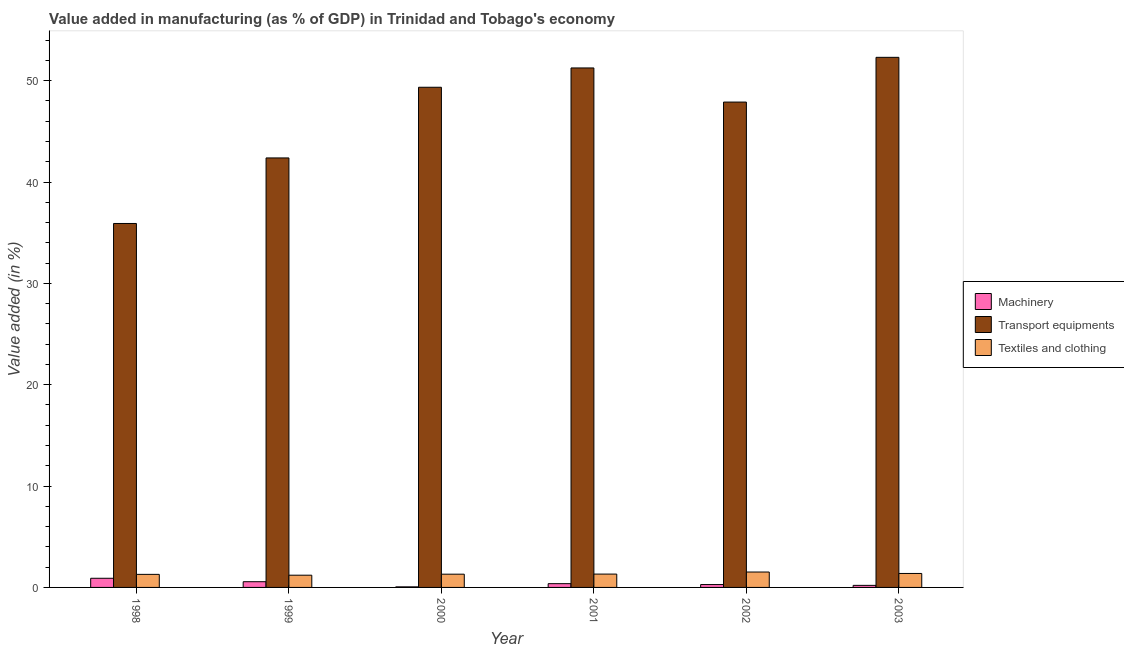How many different coloured bars are there?
Give a very brief answer. 3. How many groups of bars are there?
Make the answer very short. 6. Are the number of bars per tick equal to the number of legend labels?
Your answer should be very brief. Yes. Are the number of bars on each tick of the X-axis equal?
Your answer should be compact. Yes. How many bars are there on the 5th tick from the left?
Give a very brief answer. 3. In how many cases, is the number of bars for a given year not equal to the number of legend labels?
Provide a succinct answer. 0. What is the value added in manufacturing machinery in 2002?
Provide a succinct answer. 0.28. Across all years, what is the maximum value added in manufacturing machinery?
Give a very brief answer. 0.9. Across all years, what is the minimum value added in manufacturing transport equipments?
Ensure brevity in your answer.  35.91. In which year was the value added in manufacturing machinery minimum?
Your response must be concise. 2000. What is the total value added in manufacturing machinery in the graph?
Offer a very short reply. 2.38. What is the difference between the value added in manufacturing textile and clothing in 2000 and that in 2003?
Your answer should be compact. -0.07. What is the difference between the value added in manufacturing machinery in 2003 and the value added in manufacturing transport equipments in 2002?
Make the answer very short. -0.08. What is the average value added in manufacturing machinery per year?
Offer a terse response. 0.4. In the year 2003, what is the difference between the value added in manufacturing transport equipments and value added in manufacturing machinery?
Your answer should be very brief. 0. In how many years, is the value added in manufacturing transport equipments greater than 22 %?
Offer a very short reply. 6. What is the ratio of the value added in manufacturing machinery in 2002 to that in 2003?
Your answer should be compact. 1.39. What is the difference between the highest and the second highest value added in manufacturing transport equipments?
Keep it short and to the point. 1.05. What is the difference between the highest and the lowest value added in manufacturing machinery?
Ensure brevity in your answer.  0.85. In how many years, is the value added in manufacturing machinery greater than the average value added in manufacturing machinery taken over all years?
Provide a short and direct response. 2. What does the 3rd bar from the left in 2001 represents?
Provide a short and direct response. Textiles and clothing. What does the 2nd bar from the right in 2001 represents?
Offer a very short reply. Transport equipments. How many bars are there?
Your response must be concise. 18. Are all the bars in the graph horizontal?
Provide a short and direct response. No. How many years are there in the graph?
Your response must be concise. 6. Are the values on the major ticks of Y-axis written in scientific E-notation?
Your response must be concise. No. Does the graph contain grids?
Your answer should be very brief. No. How many legend labels are there?
Your answer should be compact. 3. How are the legend labels stacked?
Provide a succinct answer. Vertical. What is the title of the graph?
Ensure brevity in your answer.  Value added in manufacturing (as % of GDP) in Trinidad and Tobago's economy. What is the label or title of the X-axis?
Offer a terse response. Year. What is the label or title of the Y-axis?
Make the answer very short. Value added (in %). What is the Value added (in %) in Machinery in 1998?
Your answer should be very brief. 0.9. What is the Value added (in %) of Transport equipments in 1998?
Your response must be concise. 35.91. What is the Value added (in %) in Textiles and clothing in 1998?
Offer a terse response. 1.29. What is the Value added (in %) of Machinery in 1999?
Make the answer very short. 0.56. What is the Value added (in %) of Transport equipments in 1999?
Your response must be concise. 42.38. What is the Value added (in %) in Textiles and clothing in 1999?
Give a very brief answer. 1.21. What is the Value added (in %) in Machinery in 2000?
Offer a very short reply. 0.06. What is the Value added (in %) in Transport equipments in 2000?
Make the answer very short. 49.35. What is the Value added (in %) in Textiles and clothing in 2000?
Give a very brief answer. 1.31. What is the Value added (in %) in Machinery in 2001?
Provide a short and direct response. 0.37. What is the Value added (in %) in Transport equipments in 2001?
Give a very brief answer. 51.26. What is the Value added (in %) of Textiles and clothing in 2001?
Keep it short and to the point. 1.32. What is the Value added (in %) of Machinery in 2002?
Your answer should be compact. 0.28. What is the Value added (in %) of Transport equipments in 2002?
Your answer should be compact. 47.89. What is the Value added (in %) of Textiles and clothing in 2002?
Keep it short and to the point. 1.52. What is the Value added (in %) of Machinery in 2003?
Offer a terse response. 0.2. What is the Value added (in %) of Transport equipments in 2003?
Offer a very short reply. 52.3. What is the Value added (in %) of Textiles and clothing in 2003?
Offer a terse response. 1.38. Across all years, what is the maximum Value added (in %) in Machinery?
Offer a terse response. 0.9. Across all years, what is the maximum Value added (in %) of Transport equipments?
Your answer should be very brief. 52.3. Across all years, what is the maximum Value added (in %) in Textiles and clothing?
Make the answer very short. 1.52. Across all years, what is the minimum Value added (in %) of Machinery?
Give a very brief answer. 0.06. Across all years, what is the minimum Value added (in %) in Transport equipments?
Provide a short and direct response. 35.91. Across all years, what is the minimum Value added (in %) of Textiles and clothing?
Make the answer very short. 1.21. What is the total Value added (in %) of Machinery in the graph?
Make the answer very short. 2.38. What is the total Value added (in %) in Transport equipments in the graph?
Your response must be concise. 279.08. What is the total Value added (in %) of Textiles and clothing in the graph?
Provide a succinct answer. 8.02. What is the difference between the Value added (in %) in Machinery in 1998 and that in 1999?
Provide a succinct answer. 0.34. What is the difference between the Value added (in %) in Transport equipments in 1998 and that in 1999?
Your answer should be very brief. -6.47. What is the difference between the Value added (in %) of Textiles and clothing in 1998 and that in 1999?
Give a very brief answer. 0.08. What is the difference between the Value added (in %) of Machinery in 1998 and that in 2000?
Offer a terse response. 0.85. What is the difference between the Value added (in %) in Transport equipments in 1998 and that in 2000?
Keep it short and to the point. -13.44. What is the difference between the Value added (in %) in Textiles and clothing in 1998 and that in 2000?
Offer a very short reply. -0.02. What is the difference between the Value added (in %) in Machinery in 1998 and that in 2001?
Your response must be concise. 0.53. What is the difference between the Value added (in %) in Transport equipments in 1998 and that in 2001?
Give a very brief answer. -15.35. What is the difference between the Value added (in %) of Textiles and clothing in 1998 and that in 2001?
Offer a terse response. -0.03. What is the difference between the Value added (in %) of Machinery in 1998 and that in 2002?
Keep it short and to the point. 0.62. What is the difference between the Value added (in %) in Transport equipments in 1998 and that in 2002?
Your response must be concise. -11.98. What is the difference between the Value added (in %) in Textiles and clothing in 1998 and that in 2002?
Provide a succinct answer. -0.23. What is the difference between the Value added (in %) of Machinery in 1998 and that in 2003?
Give a very brief answer. 0.7. What is the difference between the Value added (in %) of Transport equipments in 1998 and that in 2003?
Make the answer very short. -16.39. What is the difference between the Value added (in %) in Textiles and clothing in 1998 and that in 2003?
Make the answer very short. -0.09. What is the difference between the Value added (in %) of Machinery in 1999 and that in 2000?
Provide a succinct answer. 0.51. What is the difference between the Value added (in %) in Transport equipments in 1999 and that in 2000?
Provide a succinct answer. -6.97. What is the difference between the Value added (in %) in Textiles and clothing in 1999 and that in 2000?
Provide a short and direct response. -0.1. What is the difference between the Value added (in %) in Machinery in 1999 and that in 2001?
Offer a terse response. 0.19. What is the difference between the Value added (in %) of Transport equipments in 1999 and that in 2001?
Make the answer very short. -8.88. What is the difference between the Value added (in %) in Textiles and clothing in 1999 and that in 2001?
Your response must be concise. -0.11. What is the difference between the Value added (in %) in Machinery in 1999 and that in 2002?
Provide a short and direct response. 0.28. What is the difference between the Value added (in %) of Transport equipments in 1999 and that in 2002?
Provide a short and direct response. -5.51. What is the difference between the Value added (in %) of Textiles and clothing in 1999 and that in 2002?
Make the answer very short. -0.31. What is the difference between the Value added (in %) in Machinery in 1999 and that in 2003?
Provide a short and direct response. 0.36. What is the difference between the Value added (in %) in Transport equipments in 1999 and that in 2003?
Provide a succinct answer. -9.93. What is the difference between the Value added (in %) of Textiles and clothing in 1999 and that in 2003?
Offer a terse response. -0.17. What is the difference between the Value added (in %) in Machinery in 2000 and that in 2001?
Make the answer very short. -0.31. What is the difference between the Value added (in %) in Transport equipments in 2000 and that in 2001?
Give a very brief answer. -1.91. What is the difference between the Value added (in %) of Textiles and clothing in 2000 and that in 2001?
Give a very brief answer. -0.01. What is the difference between the Value added (in %) of Machinery in 2000 and that in 2002?
Your answer should be compact. -0.23. What is the difference between the Value added (in %) in Transport equipments in 2000 and that in 2002?
Ensure brevity in your answer.  1.46. What is the difference between the Value added (in %) of Textiles and clothing in 2000 and that in 2002?
Make the answer very short. -0.21. What is the difference between the Value added (in %) in Machinery in 2000 and that in 2003?
Your answer should be compact. -0.15. What is the difference between the Value added (in %) of Transport equipments in 2000 and that in 2003?
Give a very brief answer. -2.95. What is the difference between the Value added (in %) of Textiles and clothing in 2000 and that in 2003?
Make the answer very short. -0.07. What is the difference between the Value added (in %) in Machinery in 2001 and that in 2002?
Make the answer very short. 0.09. What is the difference between the Value added (in %) of Transport equipments in 2001 and that in 2002?
Keep it short and to the point. 3.37. What is the difference between the Value added (in %) in Textiles and clothing in 2001 and that in 2002?
Keep it short and to the point. -0.2. What is the difference between the Value added (in %) in Machinery in 2001 and that in 2003?
Your answer should be very brief. 0.17. What is the difference between the Value added (in %) in Transport equipments in 2001 and that in 2003?
Make the answer very short. -1.05. What is the difference between the Value added (in %) of Textiles and clothing in 2001 and that in 2003?
Keep it short and to the point. -0.06. What is the difference between the Value added (in %) in Machinery in 2002 and that in 2003?
Your answer should be compact. 0.08. What is the difference between the Value added (in %) of Transport equipments in 2002 and that in 2003?
Offer a very short reply. -4.41. What is the difference between the Value added (in %) in Textiles and clothing in 2002 and that in 2003?
Offer a terse response. 0.14. What is the difference between the Value added (in %) in Machinery in 1998 and the Value added (in %) in Transport equipments in 1999?
Your response must be concise. -41.47. What is the difference between the Value added (in %) in Machinery in 1998 and the Value added (in %) in Textiles and clothing in 1999?
Provide a succinct answer. -0.3. What is the difference between the Value added (in %) of Transport equipments in 1998 and the Value added (in %) of Textiles and clothing in 1999?
Your answer should be very brief. 34.7. What is the difference between the Value added (in %) in Machinery in 1998 and the Value added (in %) in Transport equipments in 2000?
Make the answer very short. -48.45. What is the difference between the Value added (in %) of Machinery in 1998 and the Value added (in %) of Textiles and clothing in 2000?
Provide a short and direct response. -0.4. What is the difference between the Value added (in %) of Transport equipments in 1998 and the Value added (in %) of Textiles and clothing in 2000?
Provide a short and direct response. 34.6. What is the difference between the Value added (in %) of Machinery in 1998 and the Value added (in %) of Transport equipments in 2001?
Provide a succinct answer. -50.35. What is the difference between the Value added (in %) in Machinery in 1998 and the Value added (in %) in Textiles and clothing in 2001?
Keep it short and to the point. -0.41. What is the difference between the Value added (in %) in Transport equipments in 1998 and the Value added (in %) in Textiles and clothing in 2001?
Provide a succinct answer. 34.59. What is the difference between the Value added (in %) in Machinery in 1998 and the Value added (in %) in Transport equipments in 2002?
Your response must be concise. -46.99. What is the difference between the Value added (in %) of Machinery in 1998 and the Value added (in %) of Textiles and clothing in 2002?
Provide a short and direct response. -0.62. What is the difference between the Value added (in %) in Transport equipments in 1998 and the Value added (in %) in Textiles and clothing in 2002?
Provide a succinct answer. 34.39. What is the difference between the Value added (in %) in Machinery in 1998 and the Value added (in %) in Transport equipments in 2003?
Offer a very short reply. -51.4. What is the difference between the Value added (in %) of Machinery in 1998 and the Value added (in %) of Textiles and clothing in 2003?
Your answer should be compact. -0.48. What is the difference between the Value added (in %) in Transport equipments in 1998 and the Value added (in %) in Textiles and clothing in 2003?
Your answer should be compact. 34.53. What is the difference between the Value added (in %) of Machinery in 1999 and the Value added (in %) of Transport equipments in 2000?
Your response must be concise. -48.79. What is the difference between the Value added (in %) in Machinery in 1999 and the Value added (in %) in Textiles and clothing in 2000?
Your answer should be very brief. -0.74. What is the difference between the Value added (in %) of Transport equipments in 1999 and the Value added (in %) of Textiles and clothing in 2000?
Provide a short and direct response. 41.07. What is the difference between the Value added (in %) in Machinery in 1999 and the Value added (in %) in Transport equipments in 2001?
Offer a very short reply. -50.69. What is the difference between the Value added (in %) of Machinery in 1999 and the Value added (in %) of Textiles and clothing in 2001?
Keep it short and to the point. -0.75. What is the difference between the Value added (in %) in Transport equipments in 1999 and the Value added (in %) in Textiles and clothing in 2001?
Keep it short and to the point. 41.06. What is the difference between the Value added (in %) in Machinery in 1999 and the Value added (in %) in Transport equipments in 2002?
Your response must be concise. -47.32. What is the difference between the Value added (in %) of Machinery in 1999 and the Value added (in %) of Textiles and clothing in 2002?
Make the answer very short. -0.96. What is the difference between the Value added (in %) in Transport equipments in 1999 and the Value added (in %) in Textiles and clothing in 2002?
Ensure brevity in your answer.  40.86. What is the difference between the Value added (in %) in Machinery in 1999 and the Value added (in %) in Transport equipments in 2003?
Provide a succinct answer. -51.74. What is the difference between the Value added (in %) in Machinery in 1999 and the Value added (in %) in Textiles and clothing in 2003?
Offer a very short reply. -0.81. What is the difference between the Value added (in %) in Transport equipments in 1999 and the Value added (in %) in Textiles and clothing in 2003?
Provide a short and direct response. 41. What is the difference between the Value added (in %) of Machinery in 2000 and the Value added (in %) of Transport equipments in 2001?
Make the answer very short. -51.2. What is the difference between the Value added (in %) in Machinery in 2000 and the Value added (in %) in Textiles and clothing in 2001?
Offer a very short reply. -1.26. What is the difference between the Value added (in %) in Transport equipments in 2000 and the Value added (in %) in Textiles and clothing in 2001?
Ensure brevity in your answer.  48.03. What is the difference between the Value added (in %) in Machinery in 2000 and the Value added (in %) in Transport equipments in 2002?
Give a very brief answer. -47.83. What is the difference between the Value added (in %) of Machinery in 2000 and the Value added (in %) of Textiles and clothing in 2002?
Your response must be concise. -1.46. What is the difference between the Value added (in %) in Transport equipments in 2000 and the Value added (in %) in Textiles and clothing in 2002?
Ensure brevity in your answer.  47.83. What is the difference between the Value added (in %) of Machinery in 2000 and the Value added (in %) of Transport equipments in 2003?
Your answer should be very brief. -52.25. What is the difference between the Value added (in %) of Machinery in 2000 and the Value added (in %) of Textiles and clothing in 2003?
Keep it short and to the point. -1.32. What is the difference between the Value added (in %) of Transport equipments in 2000 and the Value added (in %) of Textiles and clothing in 2003?
Offer a terse response. 47.97. What is the difference between the Value added (in %) of Machinery in 2001 and the Value added (in %) of Transport equipments in 2002?
Give a very brief answer. -47.52. What is the difference between the Value added (in %) in Machinery in 2001 and the Value added (in %) in Textiles and clothing in 2002?
Keep it short and to the point. -1.15. What is the difference between the Value added (in %) of Transport equipments in 2001 and the Value added (in %) of Textiles and clothing in 2002?
Your answer should be compact. 49.74. What is the difference between the Value added (in %) in Machinery in 2001 and the Value added (in %) in Transport equipments in 2003?
Your answer should be very brief. -51.93. What is the difference between the Value added (in %) in Machinery in 2001 and the Value added (in %) in Textiles and clothing in 2003?
Provide a succinct answer. -1.01. What is the difference between the Value added (in %) in Transport equipments in 2001 and the Value added (in %) in Textiles and clothing in 2003?
Ensure brevity in your answer.  49.88. What is the difference between the Value added (in %) of Machinery in 2002 and the Value added (in %) of Transport equipments in 2003?
Provide a succinct answer. -52.02. What is the difference between the Value added (in %) in Machinery in 2002 and the Value added (in %) in Textiles and clothing in 2003?
Provide a short and direct response. -1.09. What is the difference between the Value added (in %) of Transport equipments in 2002 and the Value added (in %) of Textiles and clothing in 2003?
Your answer should be compact. 46.51. What is the average Value added (in %) of Machinery per year?
Your response must be concise. 0.4. What is the average Value added (in %) in Transport equipments per year?
Give a very brief answer. 46.51. What is the average Value added (in %) of Textiles and clothing per year?
Offer a terse response. 1.34. In the year 1998, what is the difference between the Value added (in %) of Machinery and Value added (in %) of Transport equipments?
Offer a terse response. -35.01. In the year 1998, what is the difference between the Value added (in %) in Machinery and Value added (in %) in Textiles and clothing?
Your answer should be very brief. -0.39. In the year 1998, what is the difference between the Value added (in %) of Transport equipments and Value added (in %) of Textiles and clothing?
Make the answer very short. 34.62. In the year 1999, what is the difference between the Value added (in %) of Machinery and Value added (in %) of Transport equipments?
Give a very brief answer. -41.81. In the year 1999, what is the difference between the Value added (in %) in Machinery and Value added (in %) in Textiles and clothing?
Your response must be concise. -0.64. In the year 1999, what is the difference between the Value added (in %) in Transport equipments and Value added (in %) in Textiles and clothing?
Your response must be concise. 41.17. In the year 2000, what is the difference between the Value added (in %) in Machinery and Value added (in %) in Transport equipments?
Your answer should be compact. -49.29. In the year 2000, what is the difference between the Value added (in %) in Machinery and Value added (in %) in Textiles and clothing?
Make the answer very short. -1.25. In the year 2000, what is the difference between the Value added (in %) in Transport equipments and Value added (in %) in Textiles and clothing?
Ensure brevity in your answer.  48.04. In the year 2001, what is the difference between the Value added (in %) of Machinery and Value added (in %) of Transport equipments?
Your answer should be compact. -50.88. In the year 2001, what is the difference between the Value added (in %) of Machinery and Value added (in %) of Textiles and clothing?
Provide a short and direct response. -0.95. In the year 2001, what is the difference between the Value added (in %) in Transport equipments and Value added (in %) in Textiles and clothing?
Give a very brief answer. 49.94. In the year 2002, what is the difference between the Value added (in %) of Machinery and Value added (in %) of Transport equipments?
Your answer should be very brief. -47.61. In the year 2002, what is the difference between the Value added (in %) in Machinery and Value added (in %) in Textiles and clothing?
Keep it short and to the point. -1.24. In the year 2002, what is the difference between the Value added (in %) in Transport equipments and Value added (in %) in Textiles and clothing?
Provide a succinct answer. 46.37. In the year 2003, what is the difference between the Value added (in %) of Machinery and Value added (in %) of Transport equipments?
Your answer should be compact. -52.1. In the year 2003, what is the difference between the Value added (in %) in Machinery and Value added (in %) in Textiles and clothing?
Your answer should be very brief. -1.18. In the year 2003, what is the difference between the Value added (in %) in Transport equipments and Value added (in %) in Textiles and clothing?
Your response must be concise. 50.92. What is the ratio of the Value added (in %) in Machinery in 1998 to that in 1999?
Keep it short and to the point. 1.6. What is the ratio of the Value added (in %) of Transport equipments in 1998 to that in 1999?
Ensure brevity in your answer.  0.85. What is the ratio of the Value added (in %) in Textiles and clothing in 1998 to that in 1999?
Ensure brevity in your answer.  1.07. What is the ratio of the Value added (in %) in Machinery in 1998 to that in 2000?
Your answer should be very brief. 16.04. What is the ratio of the Value added (in %) of Transport equipments in 1998 to that in 2000?
Provide a succinct answer. 0.73. What is the ratio of the Value added (in %) in Textiles and clothing in 1998 to that in 2000?
Give a very brief answer. 0.99. What is the ratio of the Value added (in %) of Machinery in 1998 to that in 2001?
Keep it short and to the point. 2.44. What is the ratio of the Value added (in %) in Transport equipments in 1998 to that in 2001?
Your response must be concise. 0.7. What is the ratio of the Value added (in %) in Textiles and clothing in 1998 to that in 2001?
Your answer should be compact. 0.98. What is the ratio of the Value added (in %) in Machinery in 1998 to that in 2002?
Give a very brief answer. 3.18. What is the ratio of the Value added (in %) in Transport equipments in 1998 to that in 2002?
Provide a short and direct response. 0.75. What is the ratio of the Value added (in %) in Textiles and clothing in 1998 to that in 2002?
Give a very brief answer. 0.85. What is the ratio of the Value added (in %) of Machinery in 1998 to that in 2003?
Provide a succinct answer. 4.44. What is the ratio of the Value added (in %) in Transport equipments in 1998 to that in 2003?
Ensure brevity in your answer.  0.69. What is the ratio of the Value added (in %) in Textiles and clothing in 1998 to that in 2003?
Provide a succinct answer. 0.94. What is the ratio of the Value added (in %) of Machinery in 1999 to that in 2000?
Keep it short and to the point. 10.02. What is the ratio of the Value added (in %) of Transport equipments in 1999 to that in 2000?
Offer a terse response. 0.86. What is the ratio of the Value added (in %) in Textiles and clothing in 1999 to that in 2000?
Offer a very short reply. 0.92. What is the ratio of the Value added (in %) in Machinery in 1999 to that in 2001?
Your answer should be very brief. 1.52. What is the ratio of the Value added (in %) in Transport equipments in 1999 to that in 2001?
Your answer should be compact. 0.83. What is the ratio of the Value added (in %) in Textiles and clothing in 1999 to that in 2001?
Offer a very short reply. 0.92. What is the ratio of the Value added (in %) of Machinery in 1999 to that in 2002?
Your response must be concise. 1.99. What is the ratio of the Value added (in %) in Transport equipments in 1999 to that in 2002?
Provide a short and direct response. 0.88. What is the ratio of the Value added (in %) of Textiles and clothing in 1999 to that in 2002?
Your answer should be compact. 0.79. What is the ratio of the Value added (in %) in Machinery in 1999 to that in 2003?
Your answer should be very brief. 2.77. What is the ratio of the Value added (in %) in Transport equipments in 1999 to that in 2003?
Keep it short and to the point. 0.81. What is the ratio of the Value added (in %) of Textiles and clothing in 1999 to that in 2003?
Your response must be concise. 0.88. What is the ratio of the Value added (in %) of Machinery in 2000 to that in 2001?
Give a very brief answer. 0.15. What is the ratio of the Value added (in %) in Transport equipments in 2000 to that in 2001?
Ensure brevity in your answer.  0.96. What is the ratio of the Value added (in %) in Machinery in 2000 to that in 2002?
Give a very brief answer. 0.2. What is the ratio of the Value added (in %) of Transport equipments in 2000 to that in 2002?
Make the answer very short. 1.03. What is the ratio of the Value added (in %) in Textiles and clothing in 2000 to that in 2002?
Ensure brevity in your answer.  0.86. What is the ratio of the Value added (in %) of Machinery in 2000 to that in 2003?
Your answer should be compact. 0.28. What is the ratio of the Value added (in %) of Transport equipments in 2000 to that in 2003?
Your answer should be compact. 0.94. What is the ratio of the Value added (in %) of Textiles and clothing in 2000 to that in 2003?
Offer a very short reply. 0.95. What is the ratio of the Value added (in %) of Machinery in 2001 to that in 2002?
Keep it short and to the point. 1.31. What is the ratio of the Value added (in %) of Transport equipments in 2001 to that in 2002?
Provide a short and direct response. 1.07. What is the ratio of the Value added (in %) in Textiles and clothing in 2001 to that in 2002?
Your answer should be very brief. 0.87. What is the ratio of the Value added (in %) in Machinery in 2001 to that in 2003?
Offer a terse response. 1.82. What is the ratio of the Value added (in %) in Transport equipments in 2001 to that in 2003?
Make the answer very short. 0.98. What is the ratio of the Value added (in %) in Textiles and clothing in 2001 to that in 2003?
Your response must be concise. 0.95. What is the ratio of the Value added (in %) of Machinery in 2002 to that in 2003?
Your answer should be very brief. 1.39. What is the ratio of the Value added (in %) in Transport equipments in 2002 to that in 2003?
Your response must be concise. 0.92. What is the ratio of the Value added (in %) in Textiles and clothing in 2002 to that in 2003?
Provide a succinct answer. 1.1. What is the difference between the highest and the second highest Value added (in %) of Machinery?
Your response must be concise. 0.34. What is the difference between the highest and the second highest Value added (in %) of Transport equipments?
Your answer should be very brief. 1.05. What is the difference between the highest and the second highest Value added (in %) in Textiles and clothing?
Your answer should be compact. 0.14. What is the difference between the highest and the lowest Value added (in %) of Machinery?
Ensure brevity in your answer.  0.85. What is the difference between the highest and the lowest Value added (in %) of Transport equipments?
Give a very brief answer. 16.39. What is the difference between the highest and the lowest Value added (in %) in Textiles and clothing?
Keep it short and to the point. 0.31. 